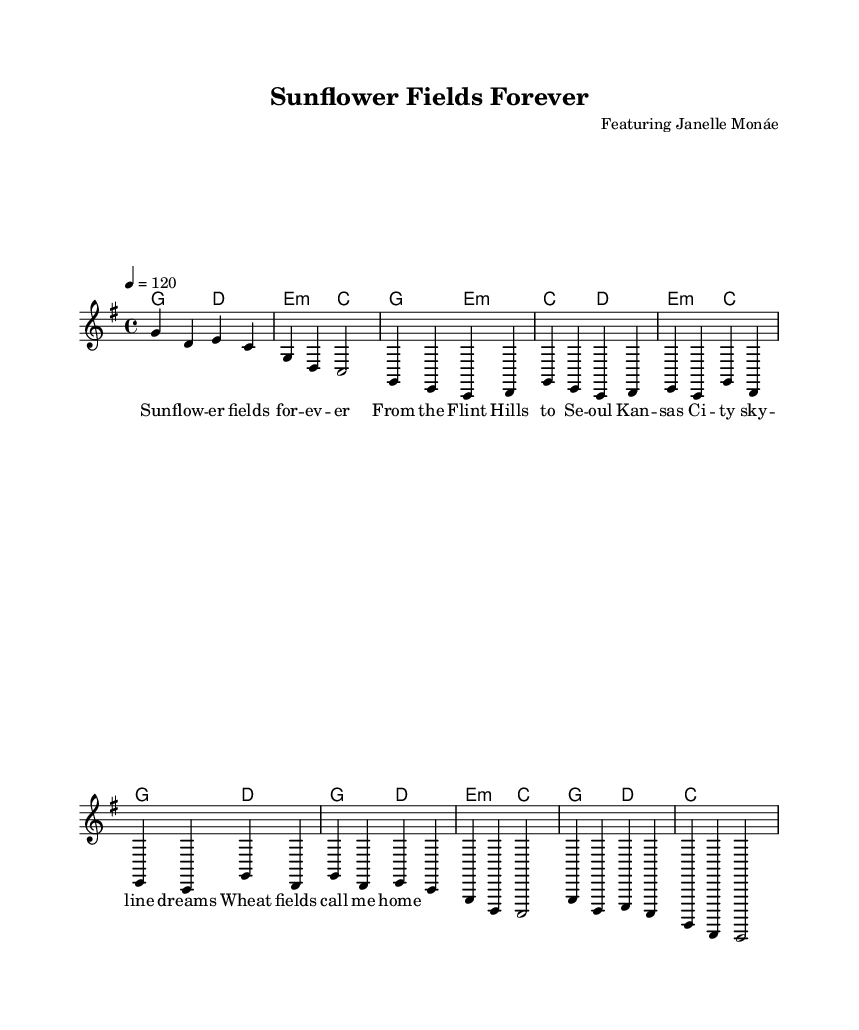What is the key signature of this music? The key signature is G major, which has one sharp (F#). You can identify the key signature at the beginning of the staff where the sharps or flats are posted.
Answer: G major What is the tempo marking of the song? The tempo is marked as 120 beats per minute (4 = 120), indicated at the beginning of the score. This tells the performer the speed of the piece.
Answer: 120 Who is the featured artist in this piece? The header of the sheet music states "Featuring Janelle Monáe," which identifies the collaboration in the song. The composer's name associated with the title provides this specific information.
Answer: Janelle Monáe Which Kansas landmark is referenced in the lyrics? The lyrics mention "Flint Hills" as a notable Kansas landmark. Referencing specific local locations shows a connection to the Kansas heritage within the lyrics.
Answer: Flint Hills What is the time signature of this music? The time signature is 4/4, indicated at the beginning of the score. This means there are four beats in each measure, a commonly used time signature in various music genres, including K-Pop.
Answer: 4/4 What is the thematic subject of the lyrics? The lyrics reflect themes of home and local identity, specifically evoking images of Kansas through the mention of natural landmarks like "Wheat fields." This suggests a strong sense of belonging and nostalgia.
Answer: Home 